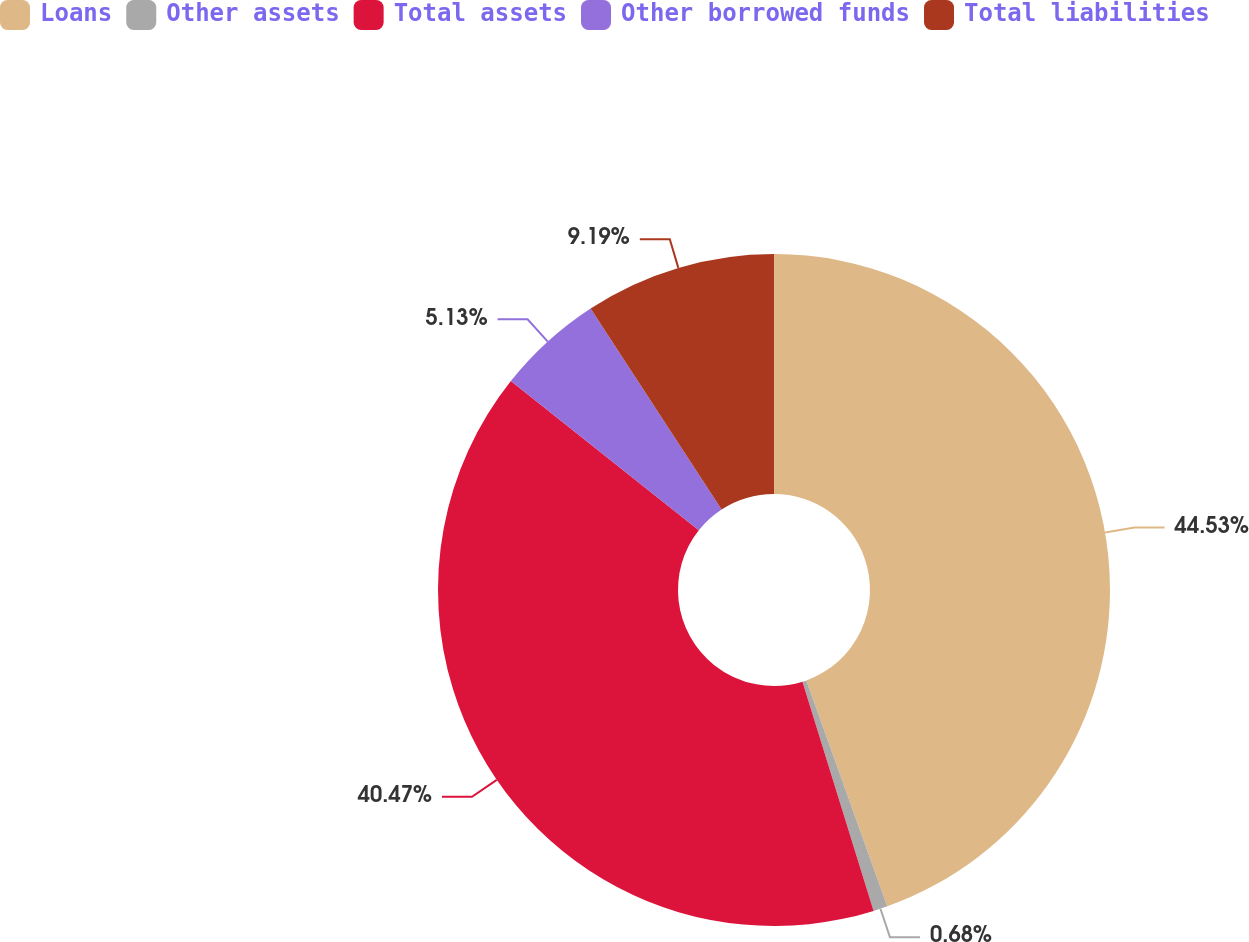Convert chart to OTSL. <chart><loc_0><loc_0><loc_500><loc_500><pie_chart><fcel>Loans<fcel>Other assets<fcel>Total assets<fcel>Other borrowed funds<fcel>Total liabilities<nl><fcel>44.53%<fcel>0.68%<fcel>40.47%<fcel>5.13%<fcel>9.19%<nl></chart> 